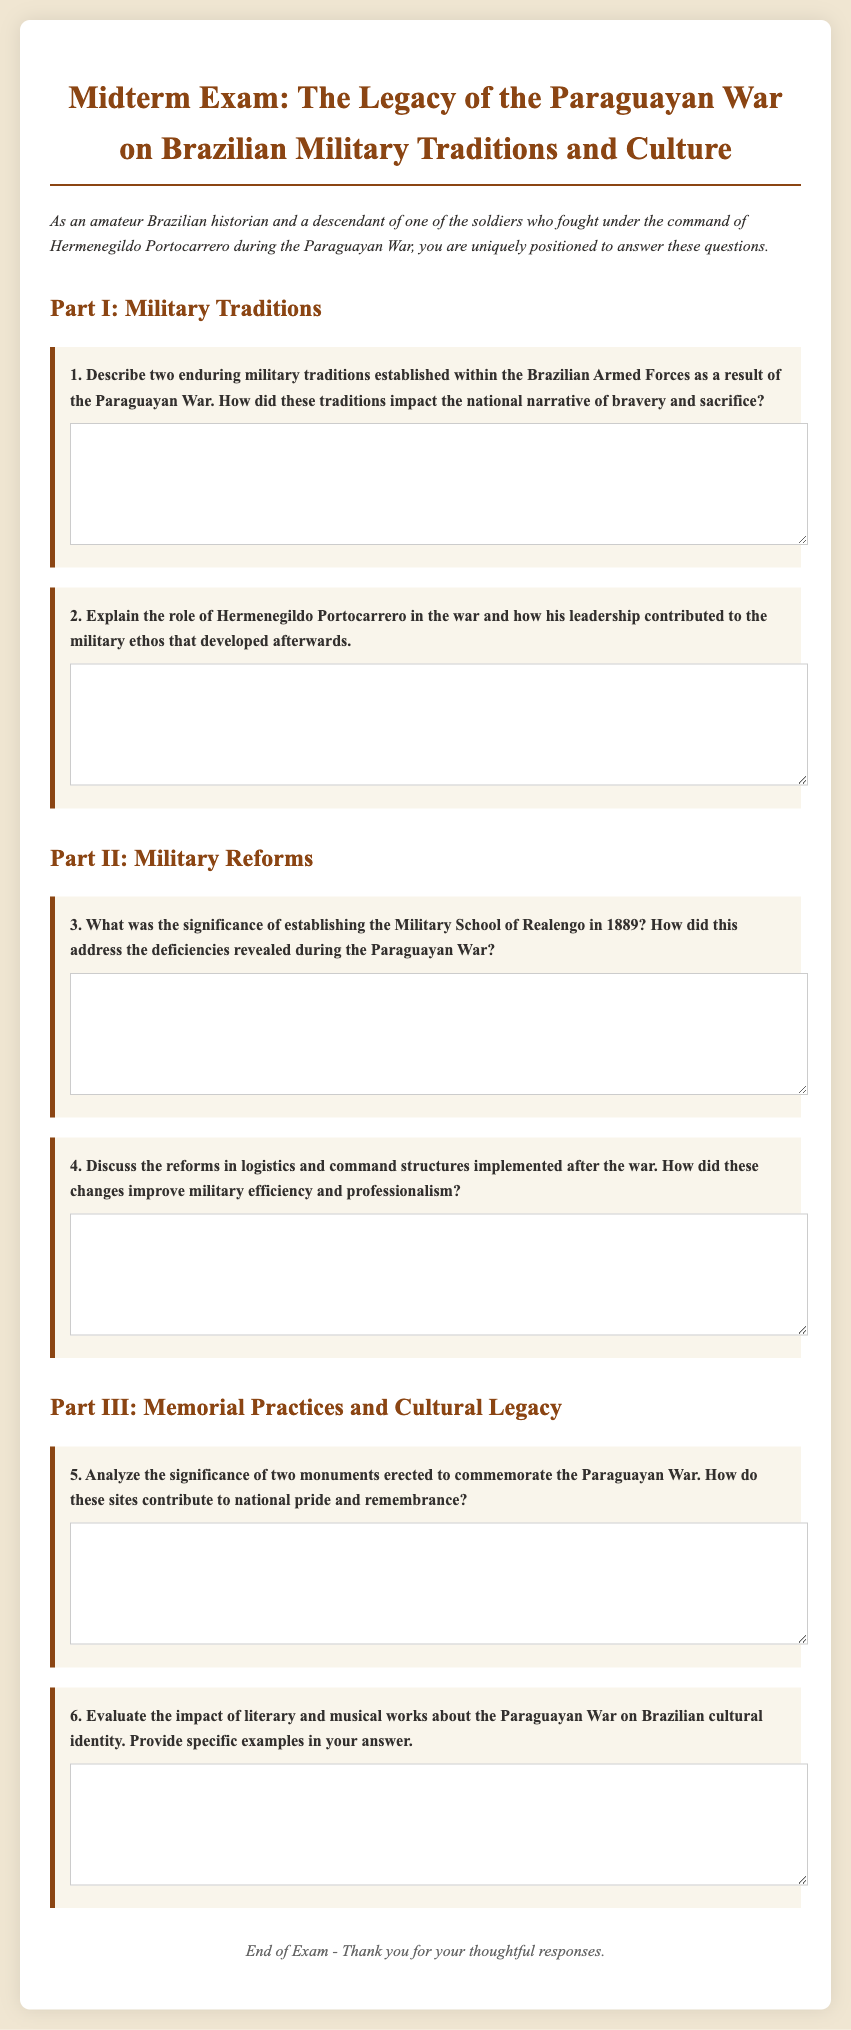What is the title of the midterm exam? The title of the midterm exam is presented prominently at the top of the document.
Answer: The Legacy of the Paraguayan War on Brazilian Military Traditions and Culture How many parts are there in the exam? The document outlines different sections for the exam: Military Traditions, Military Reforms, and Memorial Practices and Cultural Legacy.
Answer: Three Who is mentioned as a significant figure in the exam? The exam refers to Hermenegildo Portocarrero, highlighting his role during the Paraguayan War.
Answer: Hermenegildo Portocarrero What year was the Military School of Realengo established? The document specifies that the Military School of Realengo was established in 1889.
Answer: 1889 What is the purpose of the questions in Part I? The questions in Part I focus on understanding military traditions and their impact as revealed by the context of the Paraguayan War.
Answer: Military Traditions What type of responses are expected from the students? The format indicates that students should provide short answers in the text areas provided within each question box.
Answer: Short answers What does the footer of the document say? The footer usually contains concluding remarks or acknowledgments at the end of the exam, indicating its closure.
Answer: End of Exam - Thank you for your thoughtful responses How are the exam questions formatted? The exam questions are formatted with numbers and bold text for clarity, each followed by a space for student responses.
Answer: Numbered and bold text 